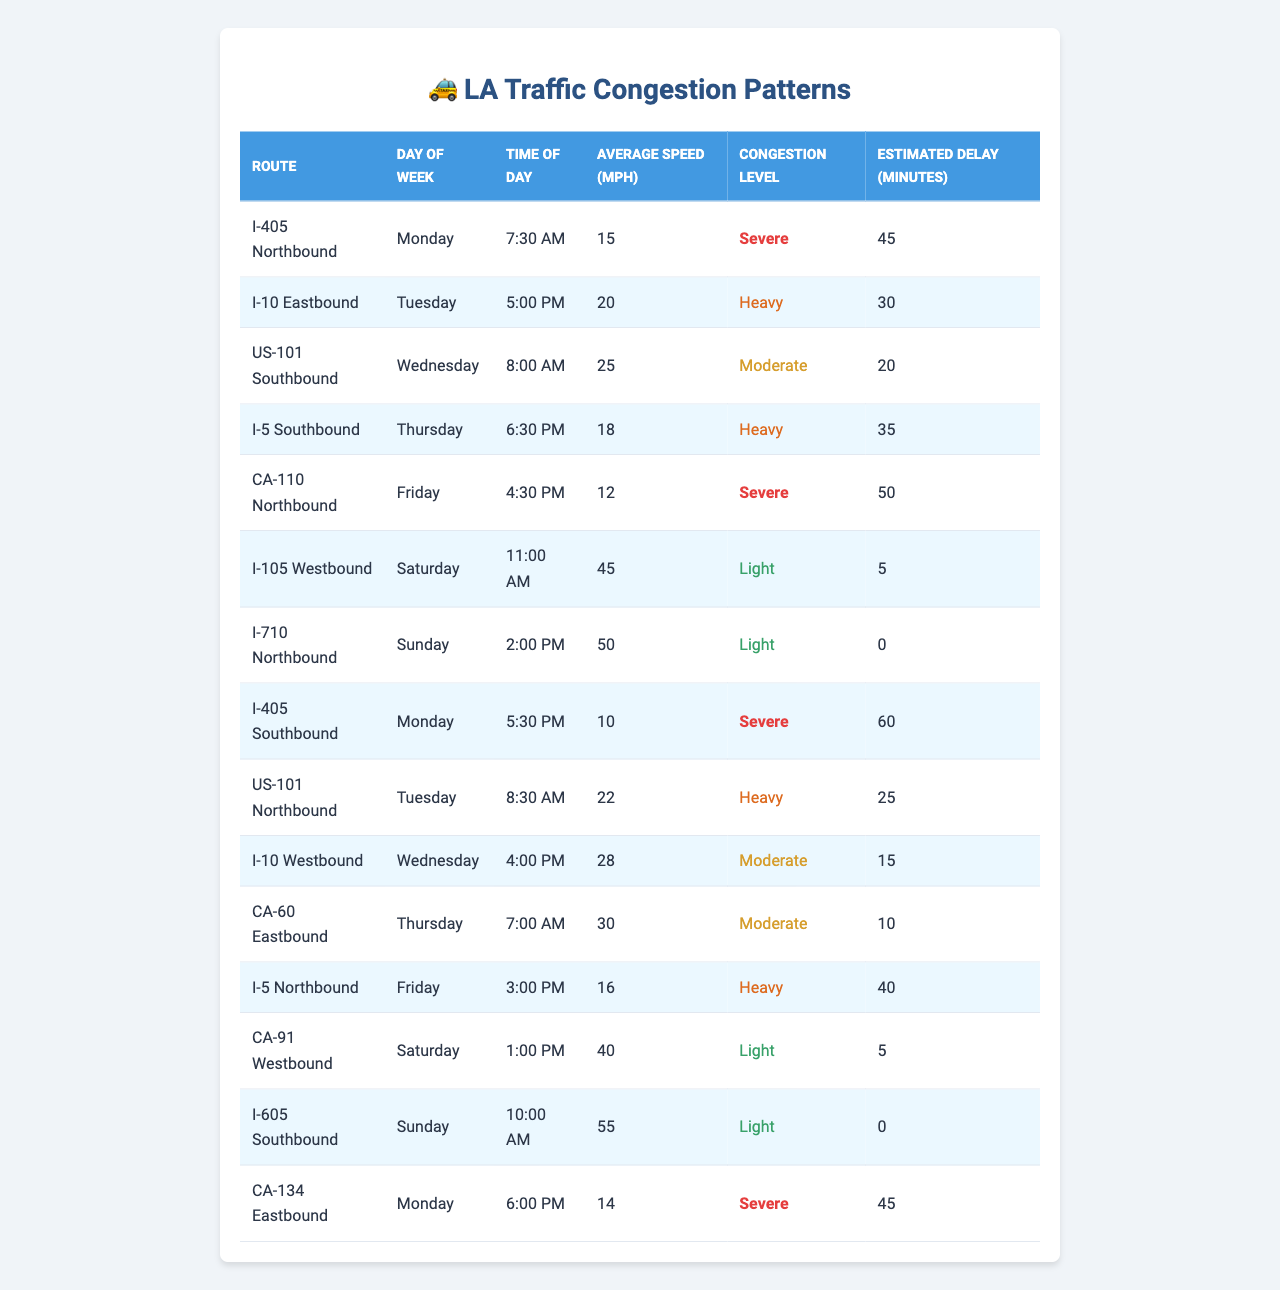What is the average speed on the I-405 Northbound during peak hours? The table shows that the average speed on the I-405 Northbound on Monday at 7:30 AM is 15 mph. Since peak hours typically refer to rush hour times, this is a relevant data point for understanding congestion.
Answer: 15 mph Which route has the highest estimated delay? In the table, the highest estimated delay is shown for the I-405 Southbound on Monday at 5:30 PM, with a delay of 60 minutes.
Answer: 60 minutes Is the congestion level for the I-10 Eastbound on Tuesday moderate? The table indicates that the congestion level for the I-10 Eastbound on Tuesday at 5:00 PM is classified as heavy, not moderate.
Answer: No What routes experience severe congestion levels? Looking through the table, routes with severe congestion levels include I-405 Northbound on Monday, I-405 Southbound on Monday, and CA-110 Northbound on Friday. Therefore, there are three severe congestion routes.
Answer: Three routes What is the average estimated delay for routes with light congestion? According to the table, there are three routes with light congestion that have the following delays: 5 minutes (I-105 Westbound), 0 minutes (I-710 Northbound), and 5 minutes (CA-91 Westbound). The average is calculated as (5 + 0 + 5) / 3 = 10 / 3 = approximately 3.33.
Answer: Approximately 3.33 minutes How many routes have a congestion level classified as heavy? From the table, the routes with a heavy congestion level are I-10 Eastbound on Tuesday, I-5 Southbound on Thursday, US-101 Northbound on Tuesday, and I-5 Northbound on Friday. This totals four routes.
Answer: Four routes What is the difference in average speed between the slowest and fastest routes during the observed times? The slowest route is I-405 Southbound on Monday with an average speed of 10 mph, and the fastest is I-710 Northbound on Sunday with an average speed of 50 mph. The difference is 50 - 10 = 40 mph.
Answer: 40 mph Are there any routes with zero estimated delays? The table shows that the I-710 Northbound on Sunday and the I-605 Southbound on Sunday both have an estimated delay of 0 minutes, indicating no congestion or delay.
Answer: Yes What day has the most instances of severe congestion? By examining the table, Monday has two routes with severe congestion (I-405 Northbound and I-405 Southbound), which is the highest for any single day.
Answer: Monday What is the total estimated delay for I-5 routes? The estimated delays for I-5 routes are 35 minutes (I-5 Southbound on Thursday) and 40 minutes (I-5 Northbound on Friday). Adding these yields 35 + 40 = 75 minutes total delay.
Answer: 75 minutes 